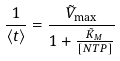Convert formula to latex. <formula><loc_0><loc_0><loc_500><loc_500>\frac { 1 } { \langle t \rangle } = \frac { \tilde { V } _ { \max } } { 1 + \frac { \tilde { K } _ { M } } { [ N T P ] } }</formula> 